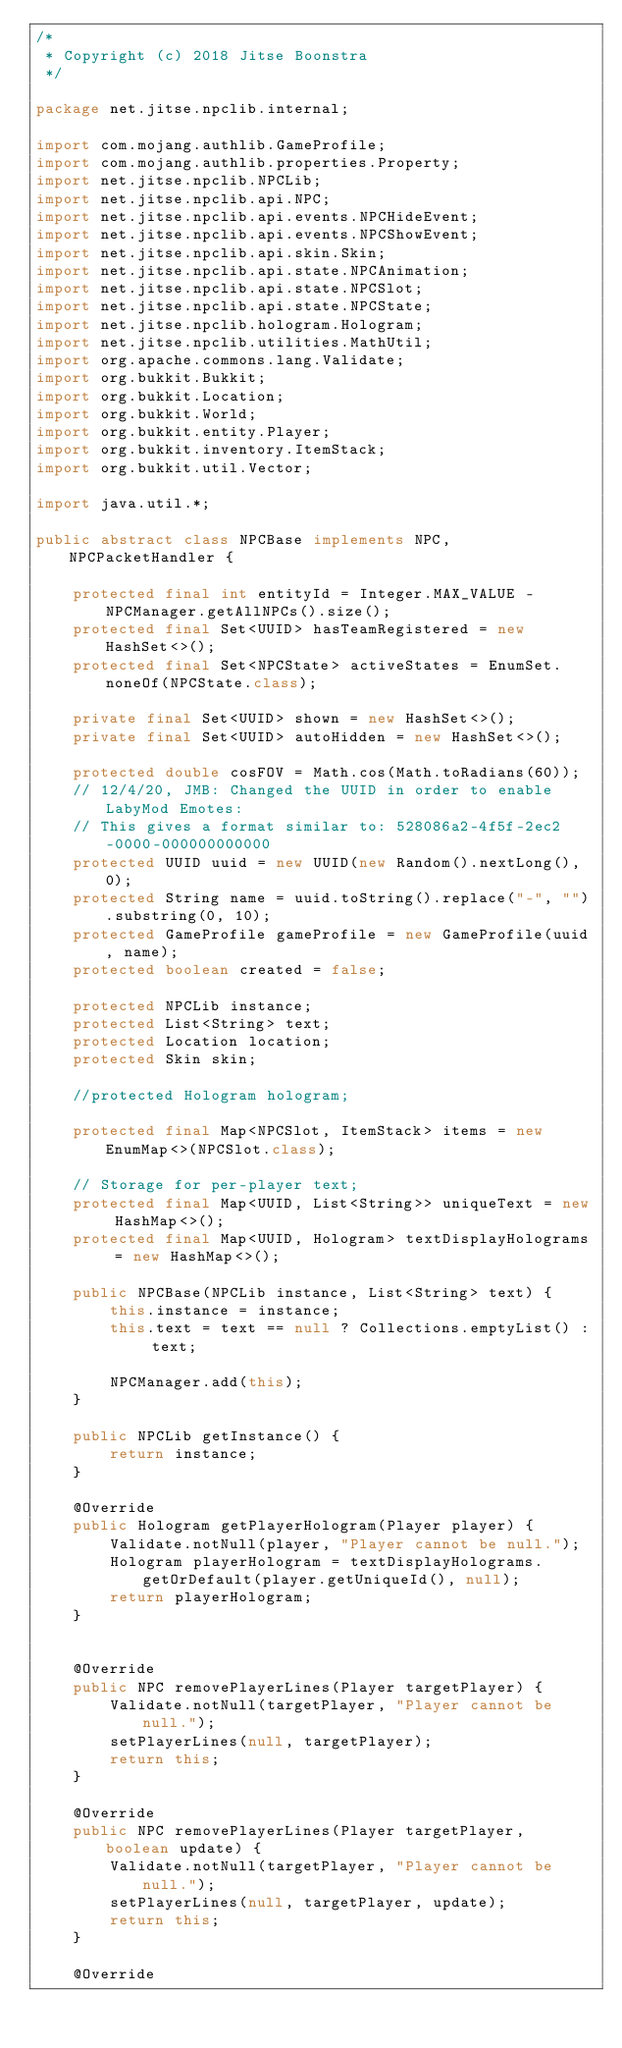Convert code to text. <code><loc_0><loc_0><loc_500><loc_500><_Java_>/*
 * Copyright (c) 2018 Jitse Boonstra
 */

package net.jitse.npclib.internal;

import com.mojang.authlib.GameProfile;
import com.mojang.authlib.properties.Property;
import net.jitse.npclib.NPCLib;
import net.jitse.npclib.api.NPC;
import net.jitse.npclib.api.events.NPCHideEvent;
import net.jitse.npclib.api.events.NPCShowEvent;
import net.jitse.npclib.api.skin.Skin;
import net.jitse.npclib.api.state.NPCAnimation;
import net.jitse.npclib.api.state.NPCSlot;
import net.jitse.npclib.api.state.NPCState;
import net.jitse.npclib.hologram.Hologram;
import net.jitse.npclib.utilities.MathUtil;
import org.apache.commons.lang.Validate;
import org.bukkit.Bukkit;
import org.bukkit.Location;
import org.bukkit.World;
import org.bukkit.entity.Player;
import org.bukkit.inventory.ItemStack;
import org.bukkit.util.Vector;

import java.util.*;

public abstract class NPCBase implements NPC, NPCPacketHandler {

    protected final int entityId = Integer.MAX_VALUE - NPCManager.getAllNPCs().size();
    protected final Set<UUID> hasTeamRegistered = new HashSet<>();
    protected final Set<NPCState> activeStates = EnumSet.noneOf(NPCState.class);

    private final Set<UUID> shown = new HashSet<>();
    private final Set<UUID> autoHidden = new HashSet<>();

    protected double cosFOV = Math.cos(Math.toRadians(60));
    // 12/4/20, JMB: Changed the UUID in order to enable LabyMod Emotes:
    // This gives a format similar to: 528086a2-4f5f-2ec2-0000-000000000000
    protected UUID uuid = new UUID(new Random().nextLong(), 0);
    protected String name = uuid.toString().replace("-", "").substring(0, 10);
    protected GameProfile gameProfile = new GameProfile(uuid, name);
    protected boolean created = false;

    protected NPCLib instance;
    protected List<String> text;
    protected Location location;
    protected Skin skin;

    //protected Hologram hologram;

    protected final Map<NPCSlot, ItemStack> items = new EnumMap<>(NPCSlot.class);

    // Storage for per-player text;
    protected final Map<UUID, List<String>> uniqueText = new HashMap<>();
    protected final Map<UUID, Hologram> textDisplayHolograms = new HashMap<>();

    public NPCBase(NPCLib instance, List<String> text) {
        this.instance = instance;
        this.text = text == null ? Collections.emptyList() : text;

        NPCManager.add(this);
    }

    public NPCLib getInstance() {
        return instance;
    }

    @Override
    public Hologram getPlayerHologram(Player player) {
        Validate.notNull(player, "Player cannot be null.");
        Hologram playerHologram = textDisplayHolograms.getOrDefault(player.getUniqueId(), null);
        return playerHologram;
    }


    @Override
    public NPC removePlayerLines(Player targetPlayer) {
        Validate.notNull(targetPlayer, "Player cannot be null.");
        setPlayerLines(null, targetPlayer);
        return this;
    }

    @Override
    public NPC removePlayerLines(Player targetPlayer, boolean update) {
        Validate.notNull(targetPlayer, "Player cannot be null.");
        setPlayerLines(null, targetPlayer, update);
        return this;
    }

    @Override</code> 